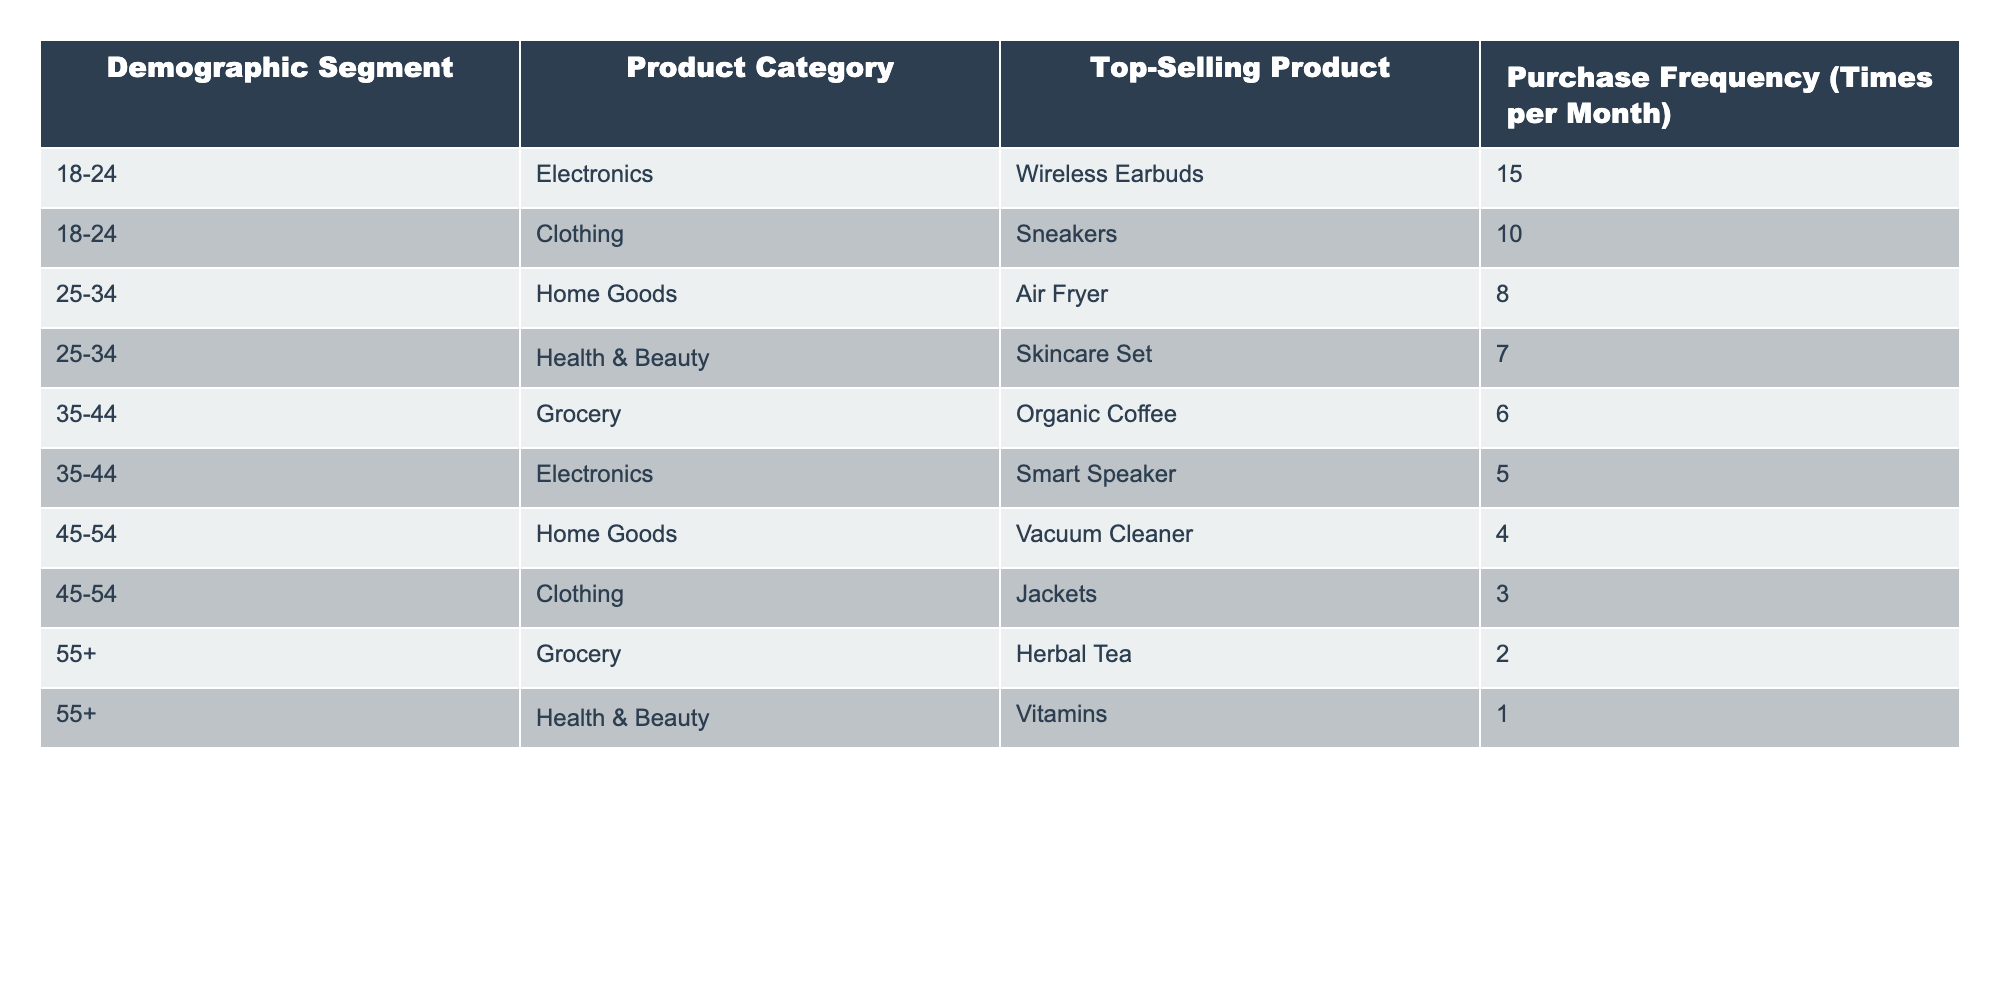What is the top-selling product in the 18-24 demographic segment? The table lists the top-selling products by demographic segment. For the 18-24 segment, the top-selling product is Wireless Earbuds.
Answer: Wireless Earbuds Which product category has the highest purchase frequency in the 25-34 demographic? In the 25-34 segment, the highest purchase frequency is associated with the Home Goods category, specifically for the Air Fryer, which has a purchase frequency of 8 times per month.
Answer: Home Goods How many times per month does the 45-54 demographic buy jackets? According to the table, the 45-54 demographic purchases jackets 3 times per month.
Answer: 3 What is the average purchase frequency for the Grocery category across all demographic segments? The table shows that the Grocery category has purchase frequencies of 6 times (Organic Coffee), 2 times (Herbal Tea) across the relevant segments. The average is calculated as (6 + 2) / 2 = 4.
Answer: 4 Is the purchase frequency for Skincare Set higher than for Organic Coffee? The purchase frequency for Skincare Set is 7 times per month, while for Organic Coffee it is 6 times. Since 7 is greater than 6, the statement is true.
Answer: Yes What is the total purchase frequency for all products in the 35-44 demographic? The purchase frequencies for the 35-44 demographic segment are 6 (Organic Coffee) and 5 (Smart Speaker). Adding these values gives 6 + 5 = 11.
Answer: 11 Which demographic segment has the least purchase frequency for health and beauty products? The table indicates that the 55+ demographic has the least purchase frequency for health and beauty products, with vitamins being purchased only 1 time per month.
Answer: 1 In which demographic segment do consumers purchase Sneakers the most? The Sneakers are purchased in the 18-24 demographic segment with a frequency of 10 times per month, which is the highest for this product.
Answer: 18-24 If the purchase frequency for Air Fryer and Skincare Set are combined, what is the total? The purchase frequency for Air Fryer is 8 and for Skincare Set is 7. The total is calculated as 8 + 7 = 15.
Answer: 15 Which product category has the lowest purchase frequency in the table? The table shows that the category with the lowest purchase frequency is Health & Beauty, with vitamins having a frequency of only 1 time per month.
Answer: Health & Beauty 